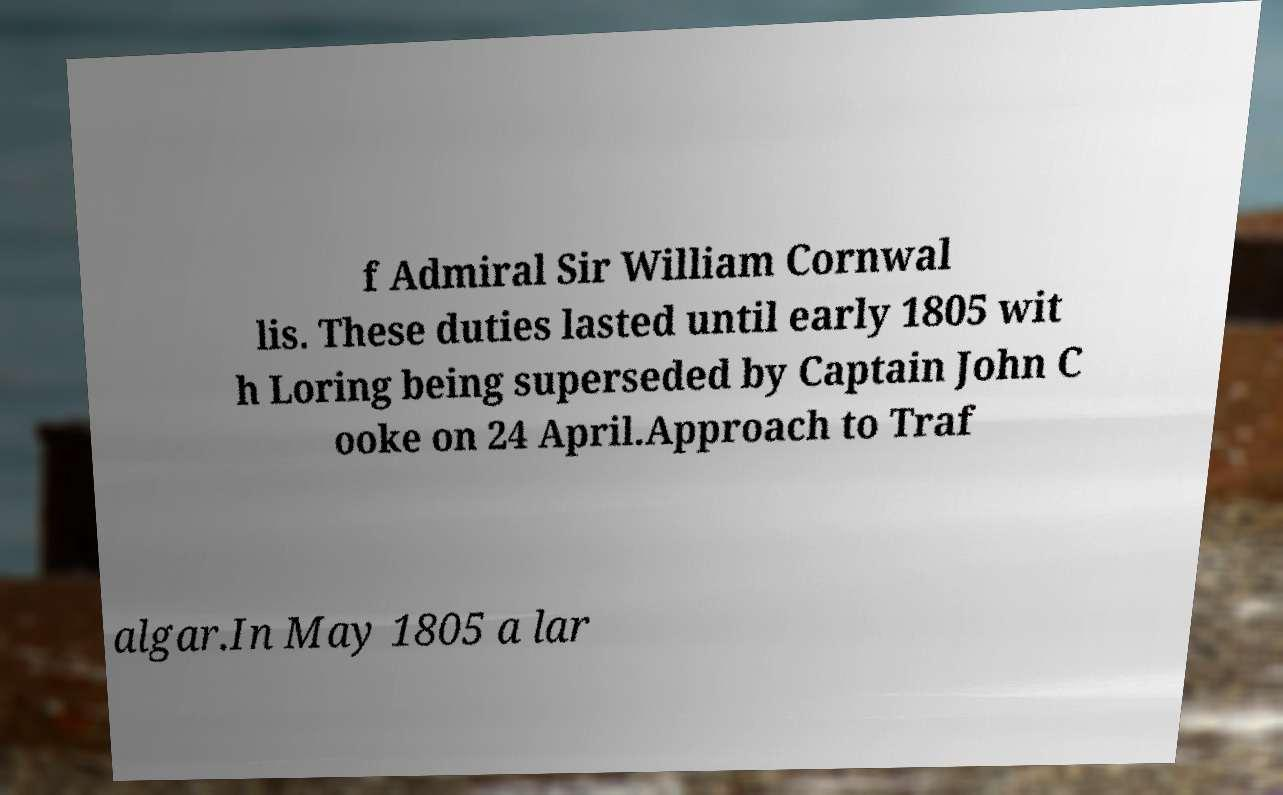For documentation purposes, I need the text within this image transcribed. Could you provide that? f Admiral Sir William Cornwal lis. These duties lasted until early 1805 wit h Loring being superseded by Captain John C ooke on 24 April.Approach to Traf algar.In May 1805 a lar 